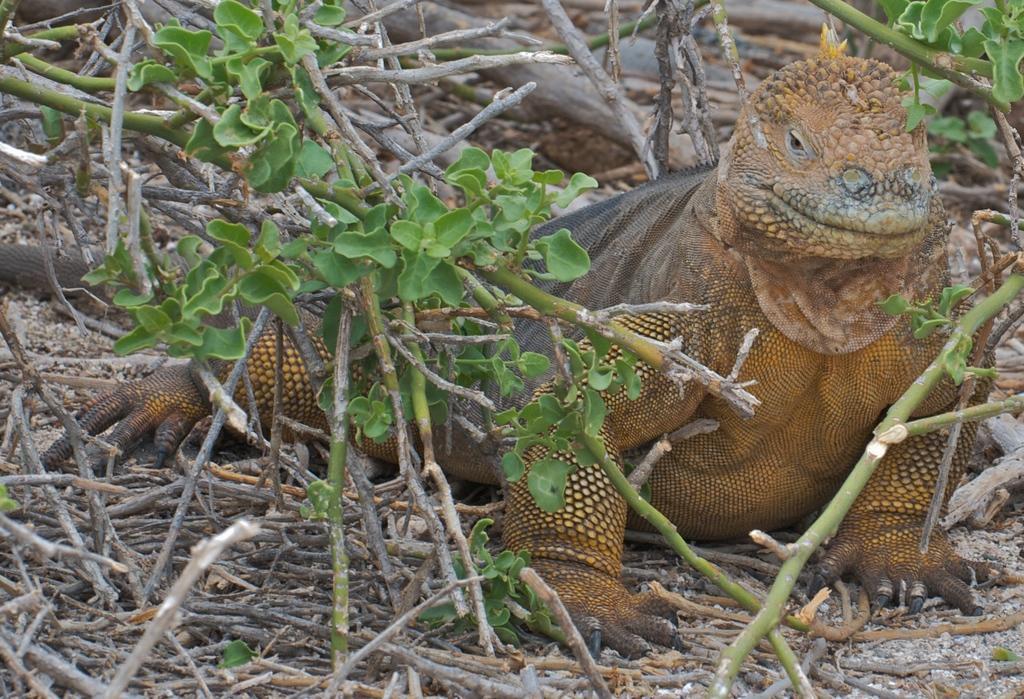Can you describe this image briefly? In this image we can see a reptile on the twigs on the ground. In the background there are plants. 